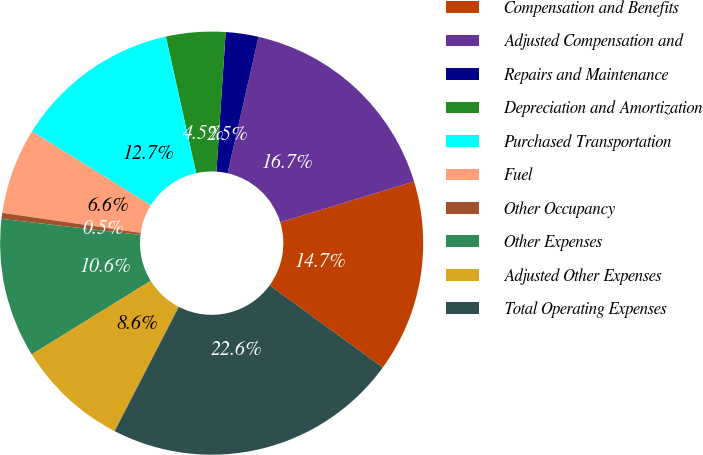Convert chart to OTSL. <chart><loc_0><loc_0><loc_500><loc_500><pie_chart><fcel>Compensation and Benefits<fcel>Adjusted Compensation and<fcel>Repairs and Maintenance<fcel>Depreciation and Amortization<fcel>Purchased Transportation<fcel>Fuel<fcel>Other Occupancy<fcel>Other Expenses<fcel>Adjusted Other Expenses<fcel>Total Operating Expenses<nl><fcel>14.71%<fcel>16.74%<fcel>2.5%<fcel>4.53%<fcel>12.67%<fcel>6.57%<fcel>0.46%<fcel>10.64%<fcel>8.6%<fcel>22.58%<nl></chart> 